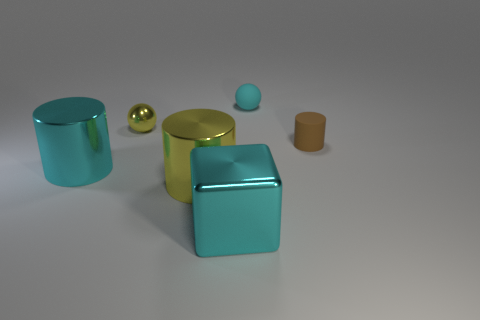There is a cyan ball; does it have the same size as the metallic object that is behind the brown matte thing?
Provide a short and direct response. Yes. There is a yellow thing that is the same shape as the tiny brown thing; what material is it?
Offer a very short reply. Metal. How many other things are the same size as the yellow sphere?
Keep it short and to the point. 2. What is the shape of the big cyan thing that is in front of the large metallic object that is behind the metallic cylinder to the right of the tiny yellow shiny thing?
Your answer should be very brief. Cube. What shape is the cyan thing that is behind the yellow cylinder and to the right of the large yellow shiny cylinder?
Offer a terse response. Sphere. What number of things are either brown shiny cylinders or rubber things on the left side of the small cylinder?
Offer a terse response. 1. Is the small cylinder made of the same material as the big yellow thing?
Offer a very short reply. No. What number of other things are there of the same shape as the tiny cyan object?
Make the answer very short. 1. There is a cyan thing that is behind the big cube and on the left side of the small cyan object; what size is it?
Keep it short and to the point. Large. How many matte things are small brown cylinders or cyan balls?
Ensure brevity in your answer.  2. 